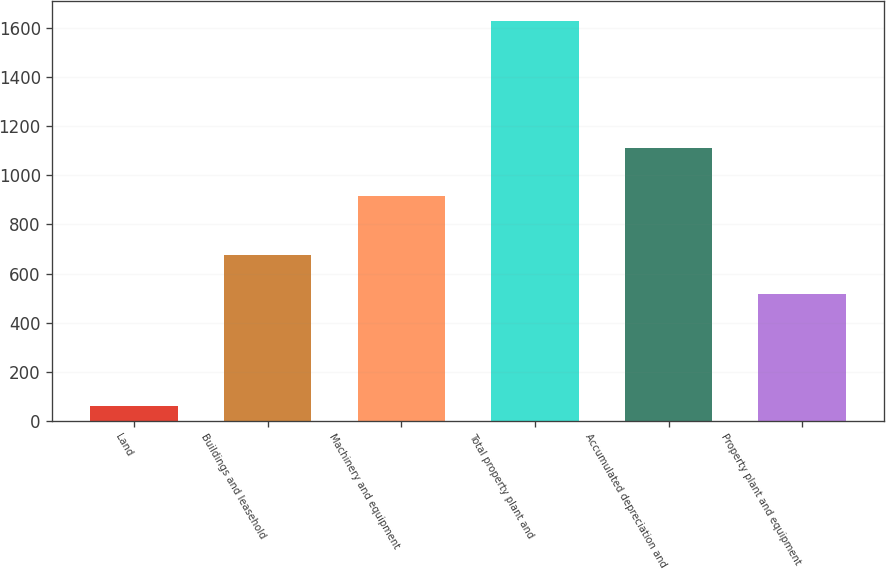<chart> <loc_0><loc_0><loc_500><loc_500><bar_chart><fcel>Land<fcel>Buildings and leasehold<fcel>Machinery and equipment<fcel>Total property plant and<fcel>Accumulated depreciation and<fcel>Property plant and equipment<nl><fcel>61<fcel>674.8<fcel>915<fcel>1629<fcel>1111<fcel>518<nl></chart> 